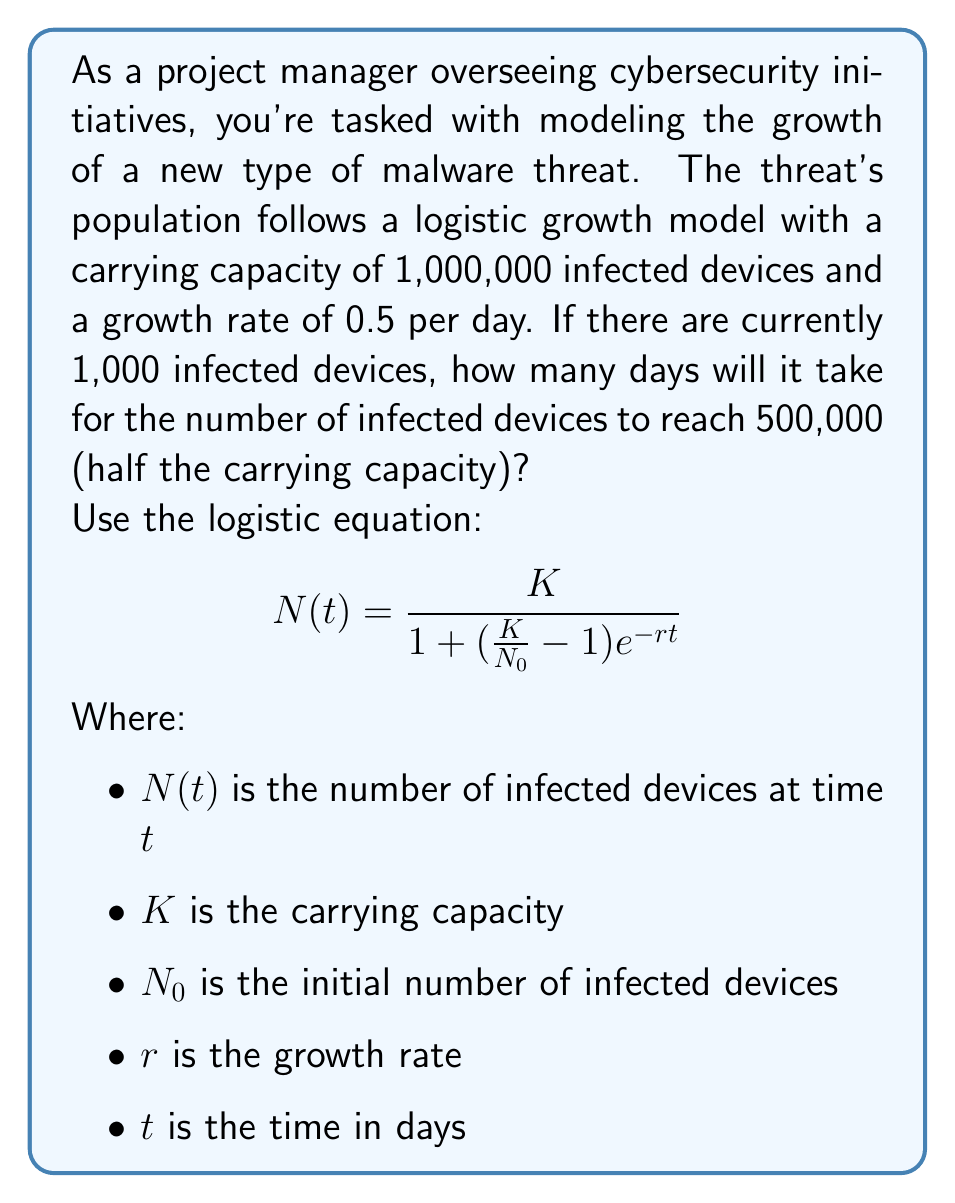Provide a solution to this math problem. To solve this problem, we'll use the logistic equation and solve for $t$:

1) Given information:
   $K = 1,000,000$ (carrying capacity)
   $N_0 = 1,000$ (initial infected devices)
   $r = 0.5$ (growth rate per day)
   $N(t) = 500,000$ (target number of infected devices)

2) Substitute these values into the logistic equation:

   $$500,000 = \frac{1,000,000}{1 + (\frac{1,000,000}{1,000} - 1)e^{-0.5t}}$$

3) Simplify:
   $$500,000 = \frac{1,000,000}{1 + 999e^{-0.5t}}$$

4) Multiply both sides by the denominator:
   $$500,000(1 + 999e^{-0.5t}) = 1,000,000$$

5) Distribute on the left side:
   $$500,000 + 499,500,000e^{-0.5t} = 1,000,000$$

6) Subtract 500,000 from both sides:
   $$499,500,000e^{-0.5t} = 500,000$$

7) Divide both sides by 499,500,000:
   $$e^{-0.5t} = \frac{1}{999}$$

8) Take the natural log of both sides:
   $$-0.5t = \ln(\frac{1}{999})$$

9) Divide both sides by -0.5:
   $$t = -\frac{2\ln(\frac{1}{999})}{1} = 2\ln(999)$$

10) Calculate the final value:
    $$t \approx 13.81$$

Therefore, it will take approximately 13.81 days for the number of infected devices to reach 500,000.
Answer: $t \approx 13.81$ days 